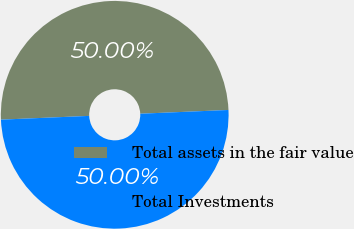Convert chart to OTSL. <chart><loc_0><loc_0><loc_500><loc_500><pie_chart><fcel>Total assets in the fair value<fcel>Total Investments<nl><fcel>50.0%<fcel>50.0%<nl></chart> 